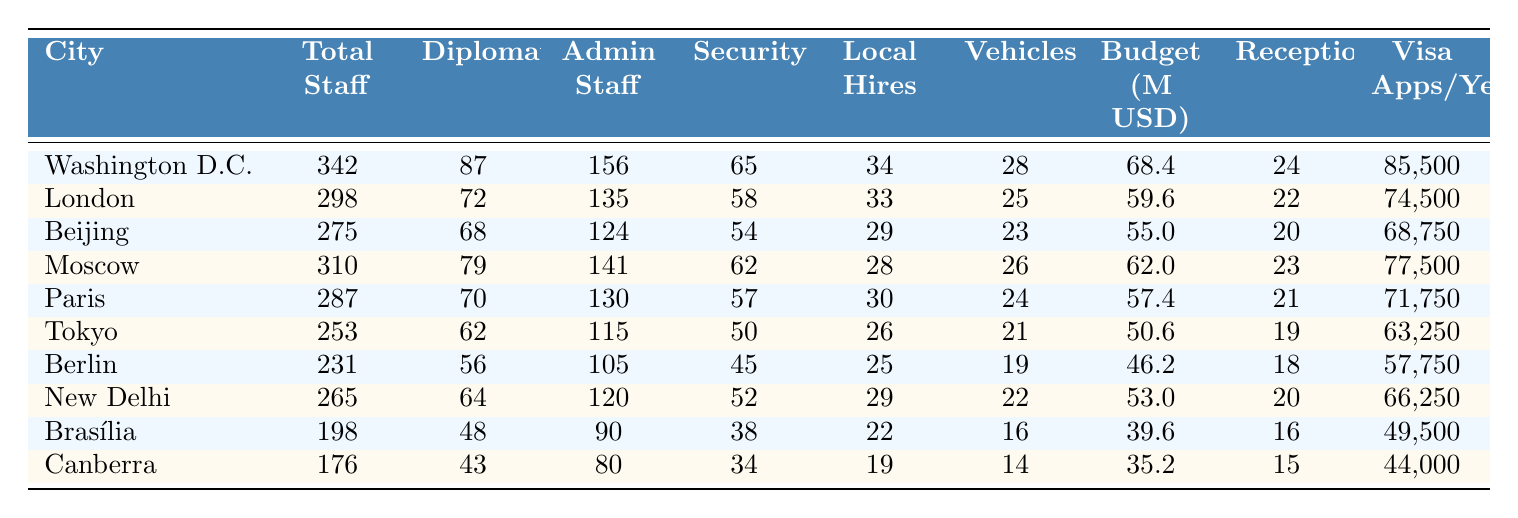What is the total staff in Washington D.C.? The table lists Washington D.C. with a total staff count of 342.
Answer: 342 How many diplomats are stationed in London? According to the table, the number of diplomats in London is 72.
Answer: 72 What is the annual budget for the diplomatic mission in Tokyo? The annual budget for Tokyo's diplomatic mission is reported as 50.6 million USD in the table.
Answer: 50.6 million USD Which city has the highest number of diplomatic vehicles? Washington D.C. has the highest number of diplomatic vehicles at 28, as shown in the table.
Answer: Washington D.C What is the total number of staff in Beijing and New Delhi combined? The total staff for Beijing is 275 and for New Delhi is 265. Adding these gives 275 + 265 = 540.
Answer: 540 How many security personnel are there in Paris? The entry for Paris shows that there are 57 security personnel at the diplomatic mission.
Answer: 57 What is the average number of visa applications processed annually across the listed cities? To find the average, sum the visa applications: (85500 + 74500 + 68750 + 77500 + 71750 + 63250 + 57750 + 66250 + 49500 + 44000) = 580000. Then divide by 10 to get the average: 580000 / 10 = 58000.
Answer: 58000 Is the statement “Beijing has more total staff than Canberra” true? The total staff for Beijing is 275, while for Canberra it is 176. Since 275 > 176, the statement is true.
Answer: Yes Which city has the least number of diplomats, and how many are there? The city with the least number of diplomats is Canberra, with 43 diplomats as per the table.
Answer: Canberra, 43 Calculate the difference in total staff between Moscow and Berlin. Moscow has 310 total staff and Berlin has 231. The difference is 310 - 231 = 79.
Answer: 79 How many diplomatic receptions per year does New Delhi have? The number of diplomatic receptions per year for New Delhi is indicated as 20 in the table.
Answer: 20 